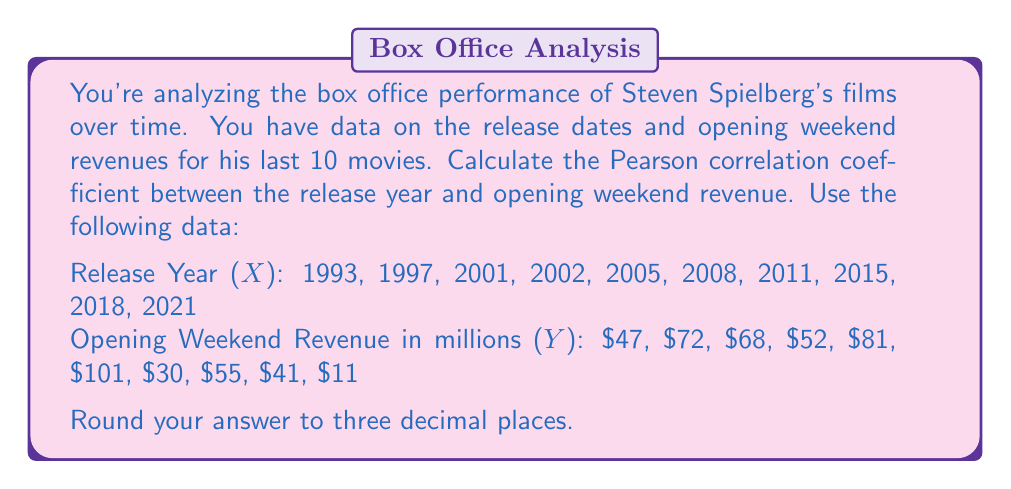Give your solution to this math problem. To calculate the Pearson correlation coefficient between release year and opening weekend revenue, we'll follow these steps:

1. Calculate the means of X and Y:
   $\bar{X} = \frac{\sum X}{n} = \frac{20101}{10} = 2010.1$
   $\bar{Y} = \frac{\sum Y}{n} = \frac{558}{10} = 55.8$

2. Calculate the deviations from the mean for X and Y:
   $x_i = X_i - \bar{X}$
   $y_i = Y_i - \bar{Y}$

3. Calculate the products of the deviations and their sum:
   $\sum x_iy_i = -1013.3$

4. Calculate the squared deviations and their sums:
   $\sum x_i^2 = 2442.9$
   $\sum y_i^2 = 5820.76$

5. Apply the Pearson correlation coefficient formula:

   $$r = \frac{\sum x_iy_i}{\sqrt{\sum x_i^2 \sum y_i^2}}$$

   $$r = \frac{-1013.3}{\sqrt{2442.9 \times 5820.76}}$$

   $$r = \frac{-1013.3}{3767.56}$$

   $$r = -0.269$$

Rounding to three decimal places, we get -0.269.
Answer: -0.269 